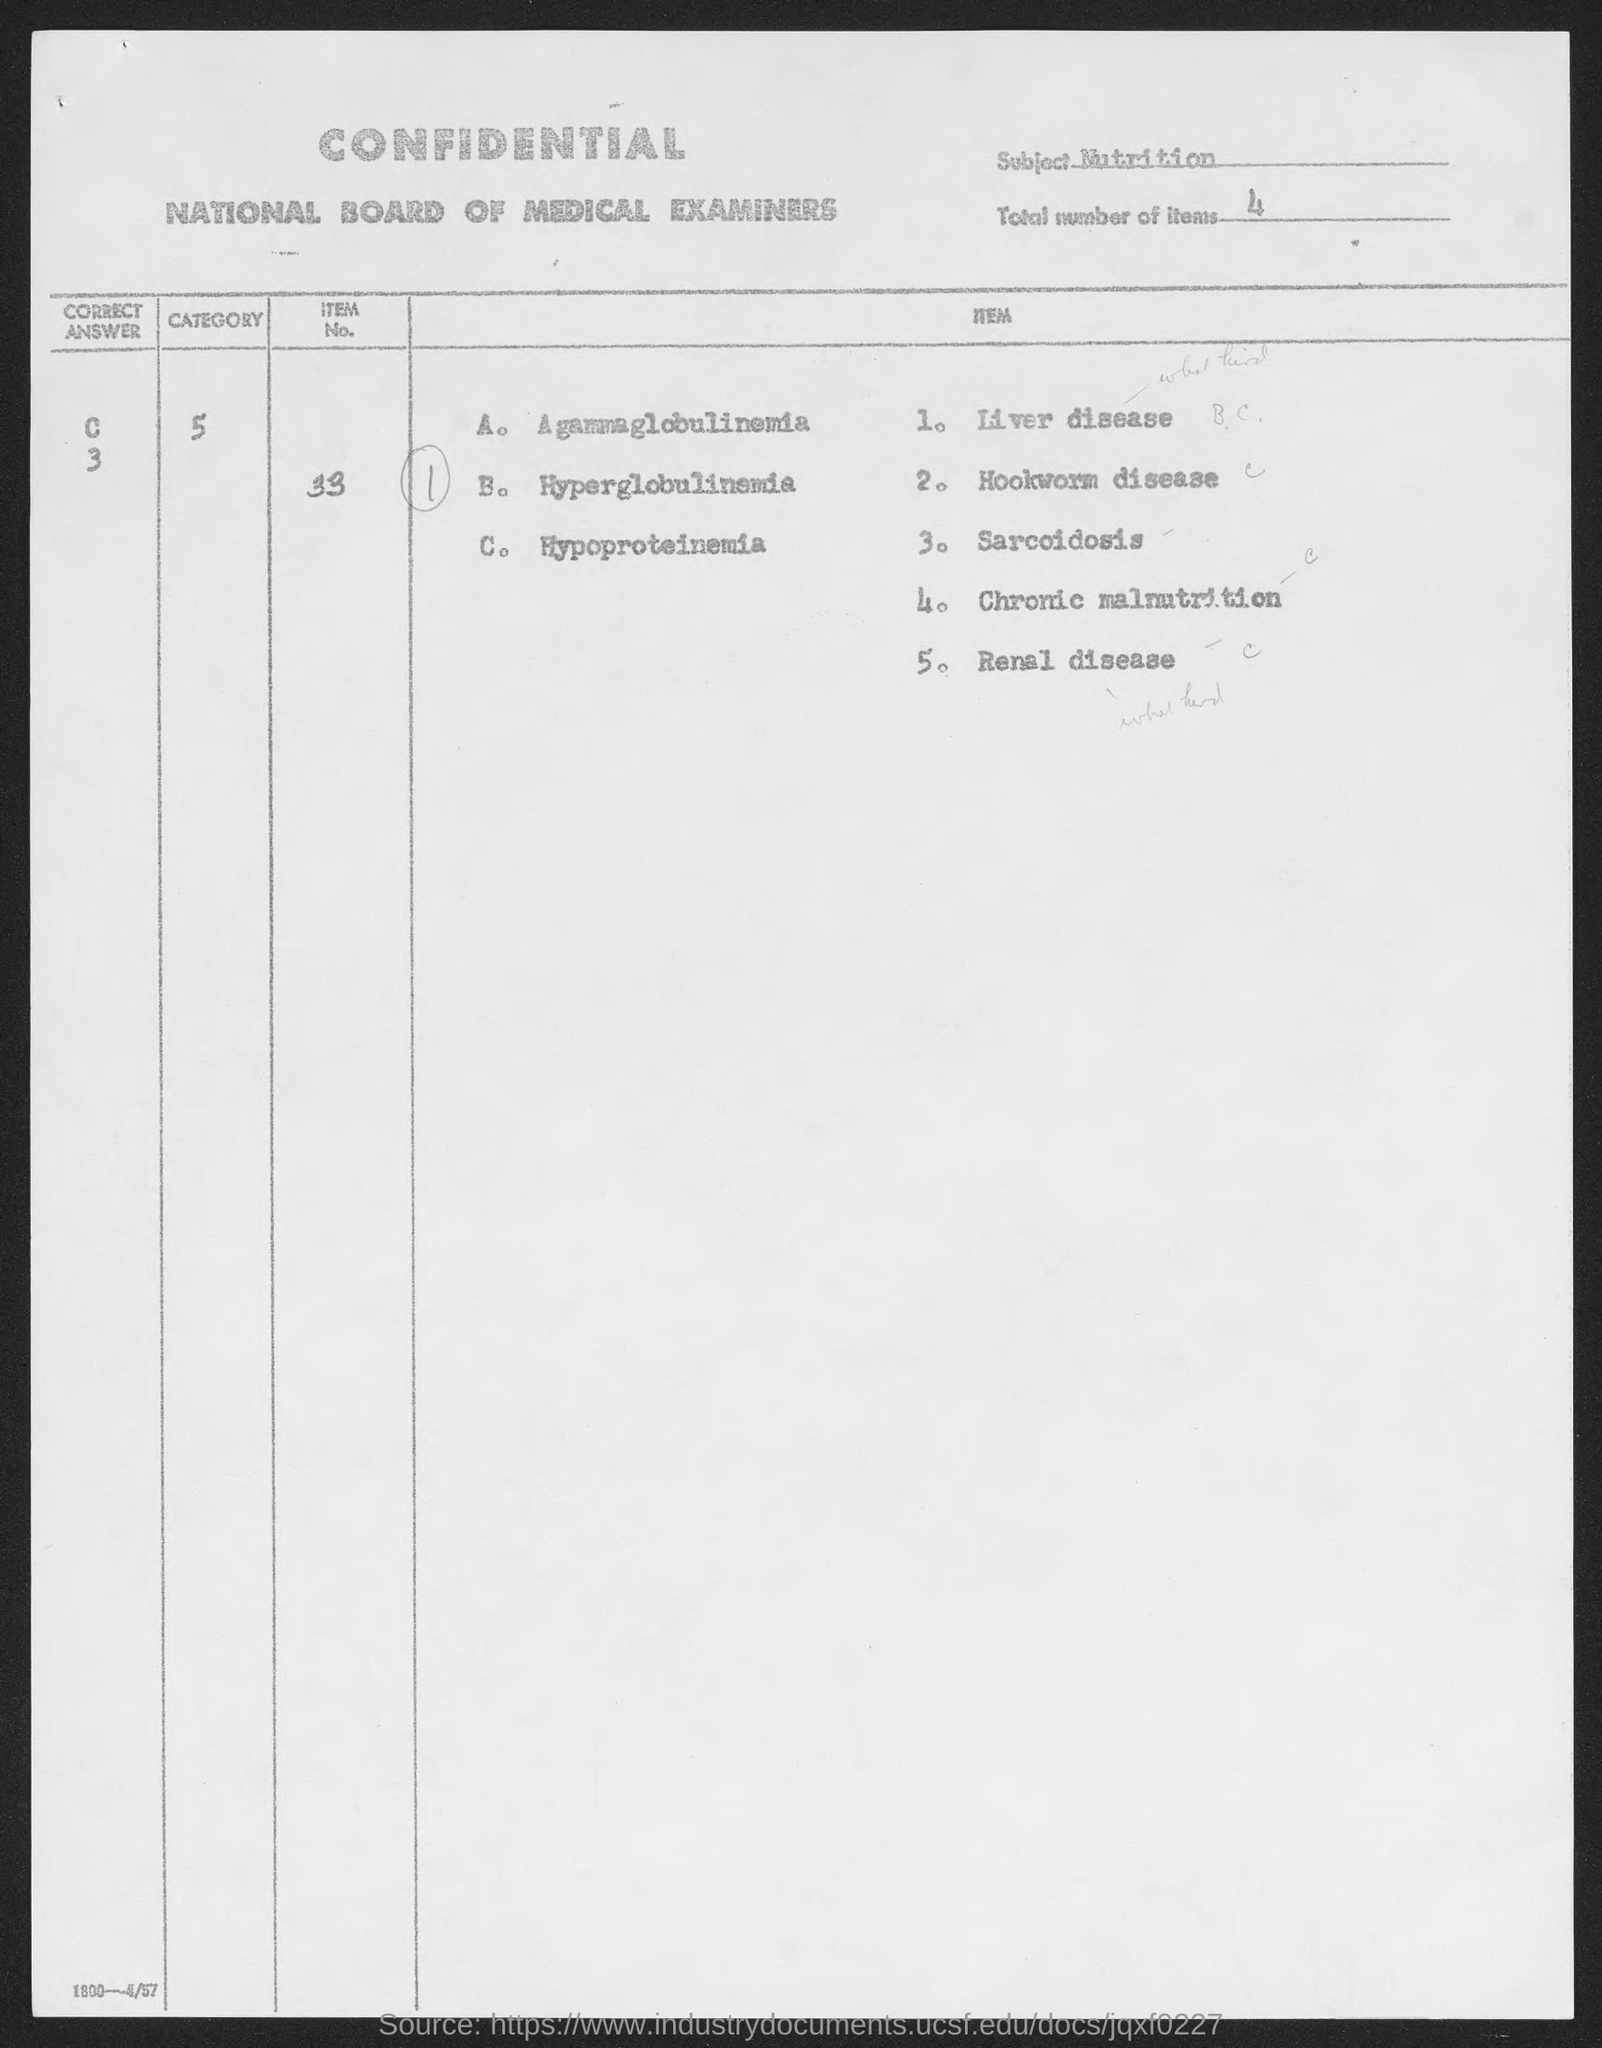What is the subject mentioned in the document?
Keep it short and to the point. Nutrition. What is the total number of items given in the document?
Offer a terse response. 4. What is the Item No. given in the document?
Make the answer very short. 33. 